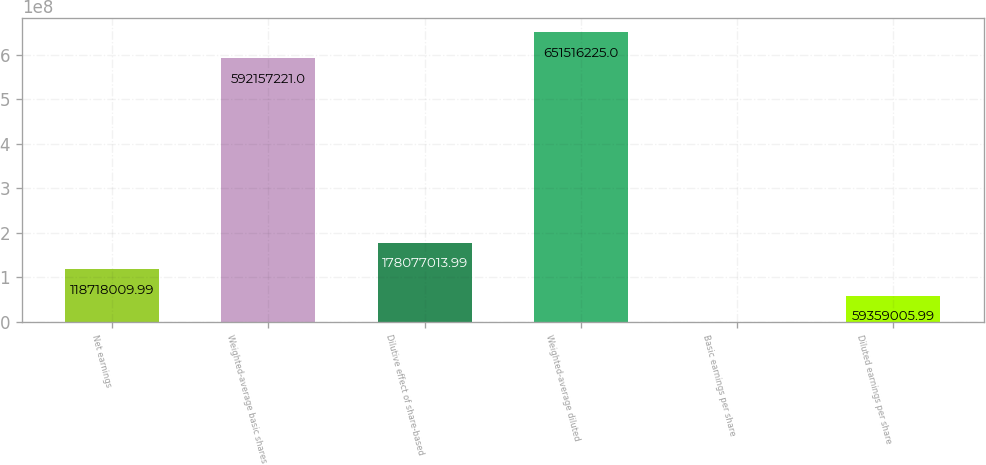Convert chart to OTSL. <chart><loc_0><loc_0><loc_500><loc_500><bar_chart><fcel>Net earnings<fcel>Weighted-average basic shares<fcel>Dilutive effect of share-based<fcel>Weighted-average diluted<fcel>Basic earnings per share<fcel>Diluted earnings per share<nl><fcel>1.18718e+08<fcel>5.92157e+08<fcel>1.78077e+08<fcel>6.51516e+08<fcel>1.99<fcel>5.9359e+07<nl></chart> 